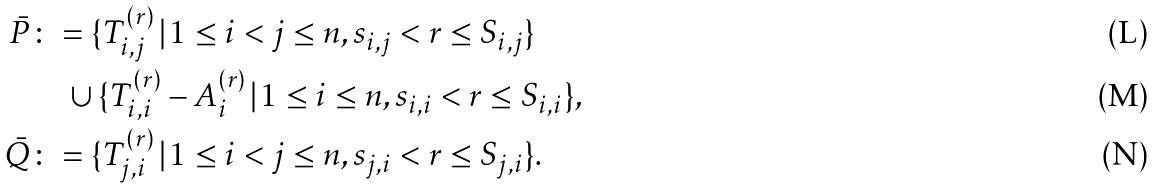<formula> <loc_0><loc_0><loc_500><loc_500>\bar { P } & \colon = \{ T _ { i , j } ^ { ( r ) } \, | \, 1 \leq i < j \leq n , s _ { i , j } < r \leq S _ { i , j } \} \\ & \quad \cup \{ T _ { i , i } ^ { ( r ) } - A _ { i } ^ { ( r ) } \, | \, 1 \leq i \leq n , s _ { i , i } < r \leq S _ { i , i } \} , \\ \bar { Q } & \colon = \{ T _ { j , i } ^ { ( r ) } \, | \, 1 \leq i < j \leq n , s _ { j , i } < r \leq S _ { j , i } \} .</formula> 